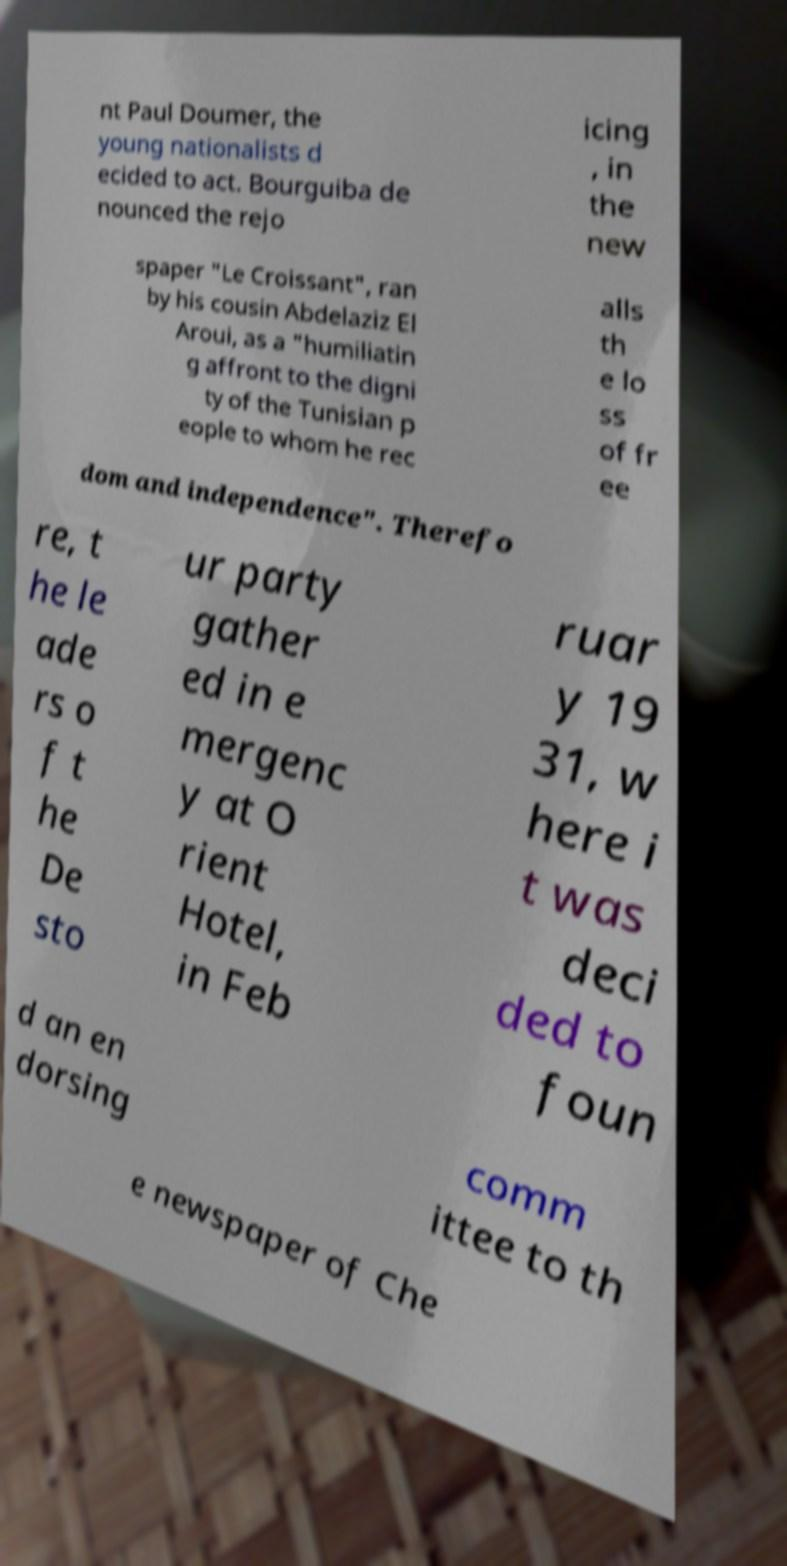Could you extract and type out the text from this image? nt Paul Doumer, the young nationalists d ecided to act. Bourguiba de nounced the rejo icing , in the new spaper "Le Croissant", ran by his cousin Abdelaziz El Aroui, as a "humiliatin g affront to the digni ty of the Tunisian p eople to whom he rec alls th e lo ss of fr ee dom and independence". Therefo re, t he le ade rs o f t he De sto ur party gather ed in e mergenc y at O rient Hotel, in Feb ruar y 19 31, w here i t was deci ded to foun d an en dorsing comm ittee to th e newspaper of Che 